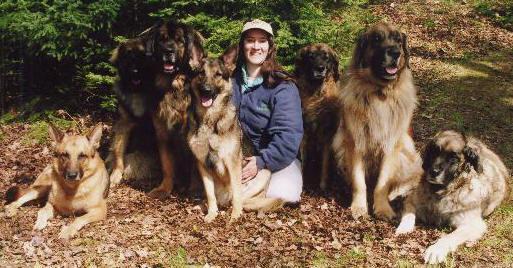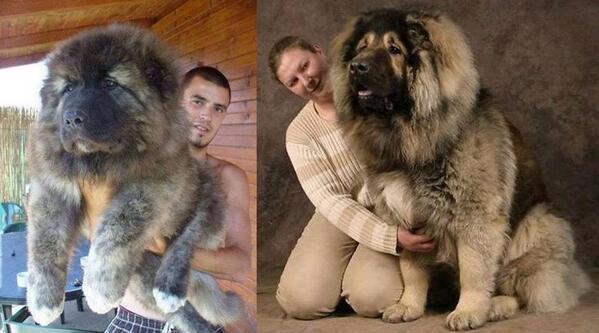The first image is the image on the left, the second image is the image on the right. Examine the images to the left and right. Is the description "One image shows at least five similar looking dogs posed sitting upright on grass in front of a house, with no humans present." accurate? Answer yes or no. No. The first image is the image on the left, the second image is the image on the right. Assess this claim about the two images: "There are no more than two dogs in the right image.". Correct or not? Answer yes or no. Yes. 